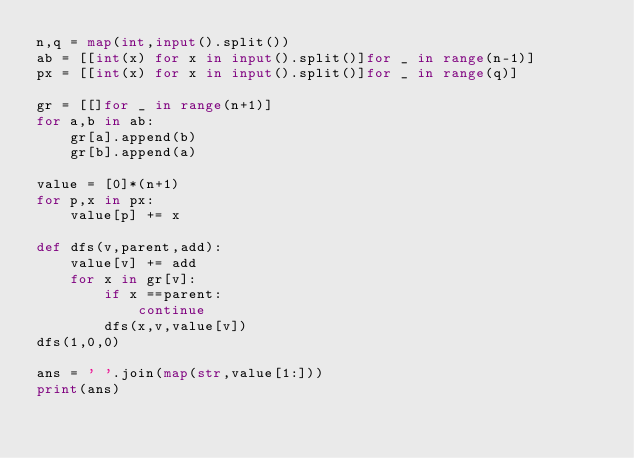<code> <loc_0><loc_0><loc_500><loc_500><_Python_>n,q = map(int,input().split())
ab = [[int(x) for x in input().split()]for _ in range(n-1)]
px = [[int(x) for x in input().split()]for _ in range(q)]

gr = [[]for _ in range(n+1)]
for a,b in ab:
    gr[a].append(b)
    gr[b].append(a)

value = [0]*(n+1)
for p,x in px:
    value[p] += x

def dfs(v,parent,add):
    value[v] += add
    for x in gr[v]:
        if x ==parent:
            continue
        dfs(x,v,value[v])
dfs(1,0,0)

ans = ' '.join(map(str,value[1:]))
print(ans)</code> 